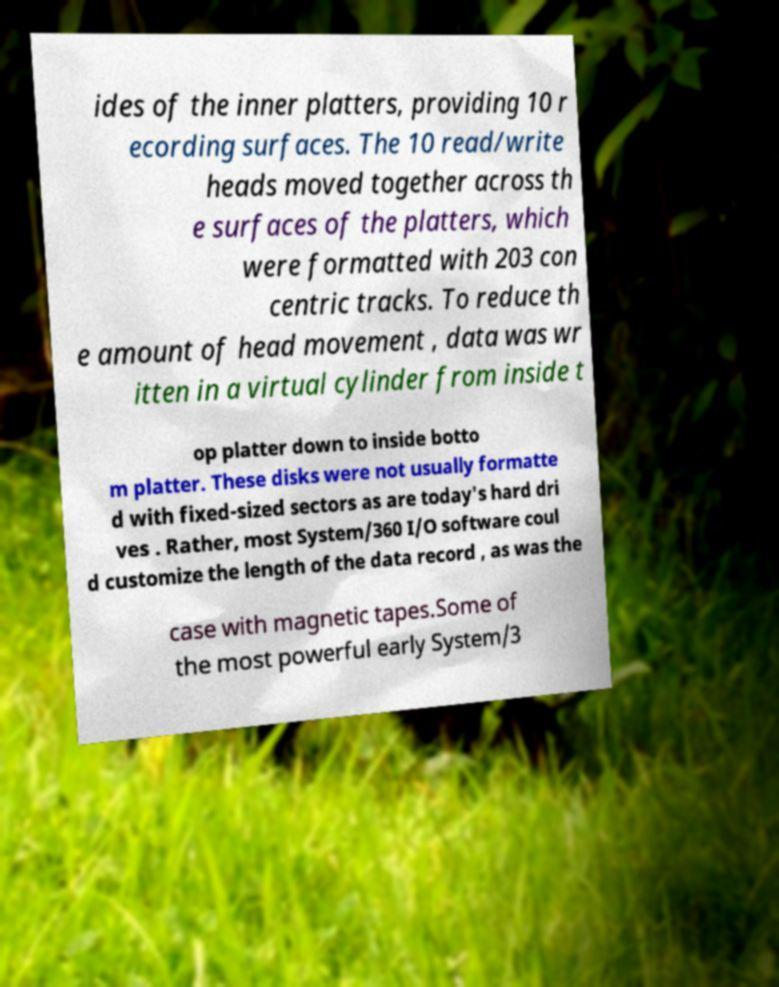There's text embedded in this image that I need extracted. Can you transcribe it verbatim? ides of the inner platters, providing 10 r ecording surfaces. The 10 read/write heads moved together across th e surfaces of the platters, which were formatted with 203 con centric tracks. To reduce th e amount of head movement , data was wr itten in a virtual cylinder from inside t op platter down to inside botto m platter. These disks were not usually formatte d with fixed-sized sectors as are today's hard dri ves . Rather, most System/360 I/O software coul d customize the length of the data record , as was the case with magnetic tapes.Some of the most powerful early System/3 